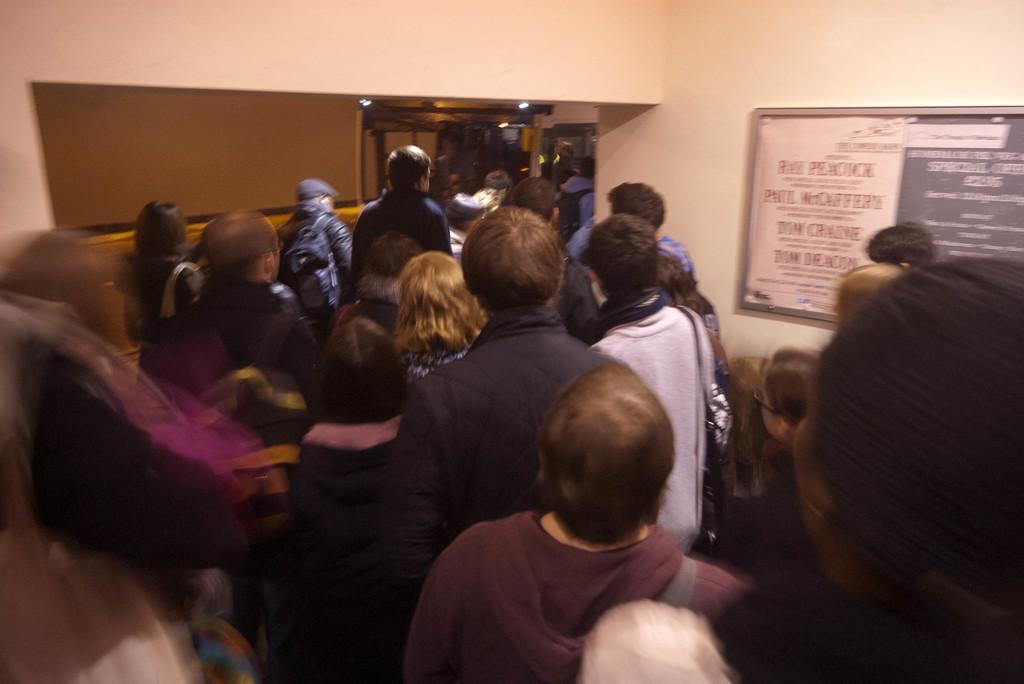How would you summarize this image in a sentence or two? In this picture there are people and we can see board on the wall. In the background of the image we can see lights. 